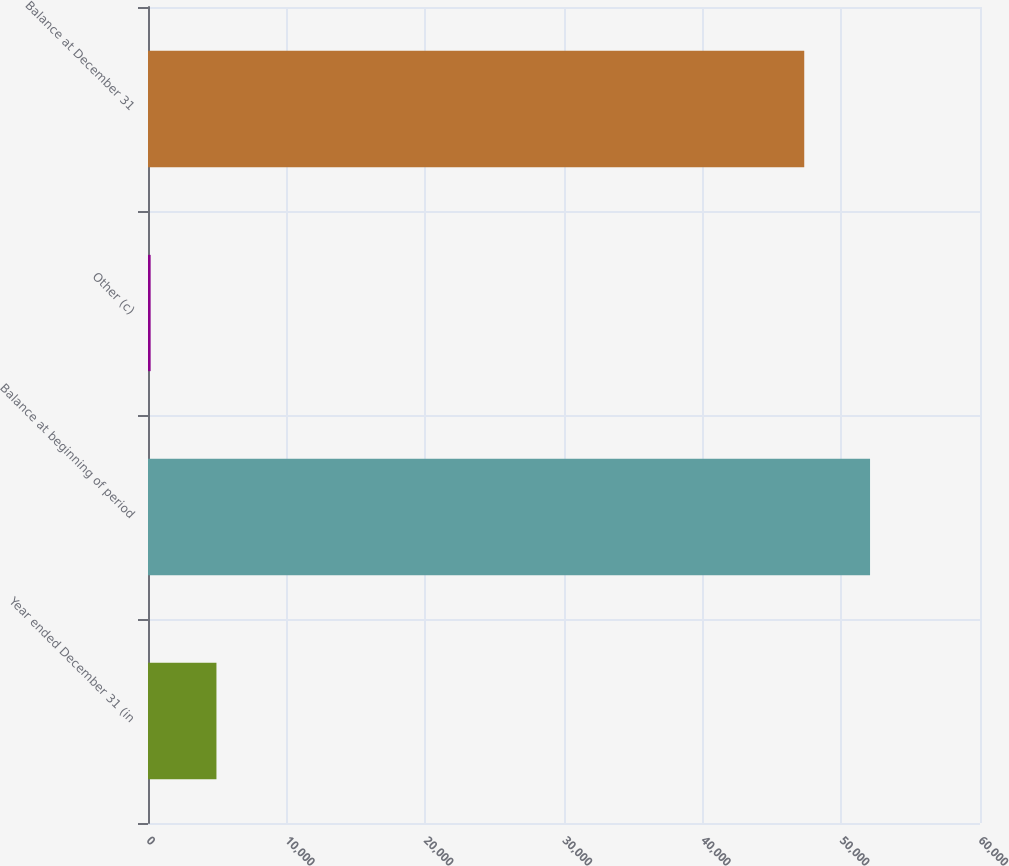Convert chart to OTSL. <chart><loc_0><loc_0><loc_500><loc_500><bar_chart><fcel>Year ended December 31 (in<fcel>Balance at beginning of period<fcel>Other (c)<fcel>Balance at December 31<nl><fcel>4935.7<fcel>52070.7<fcel>190<fcel>47325<nl></chart> 